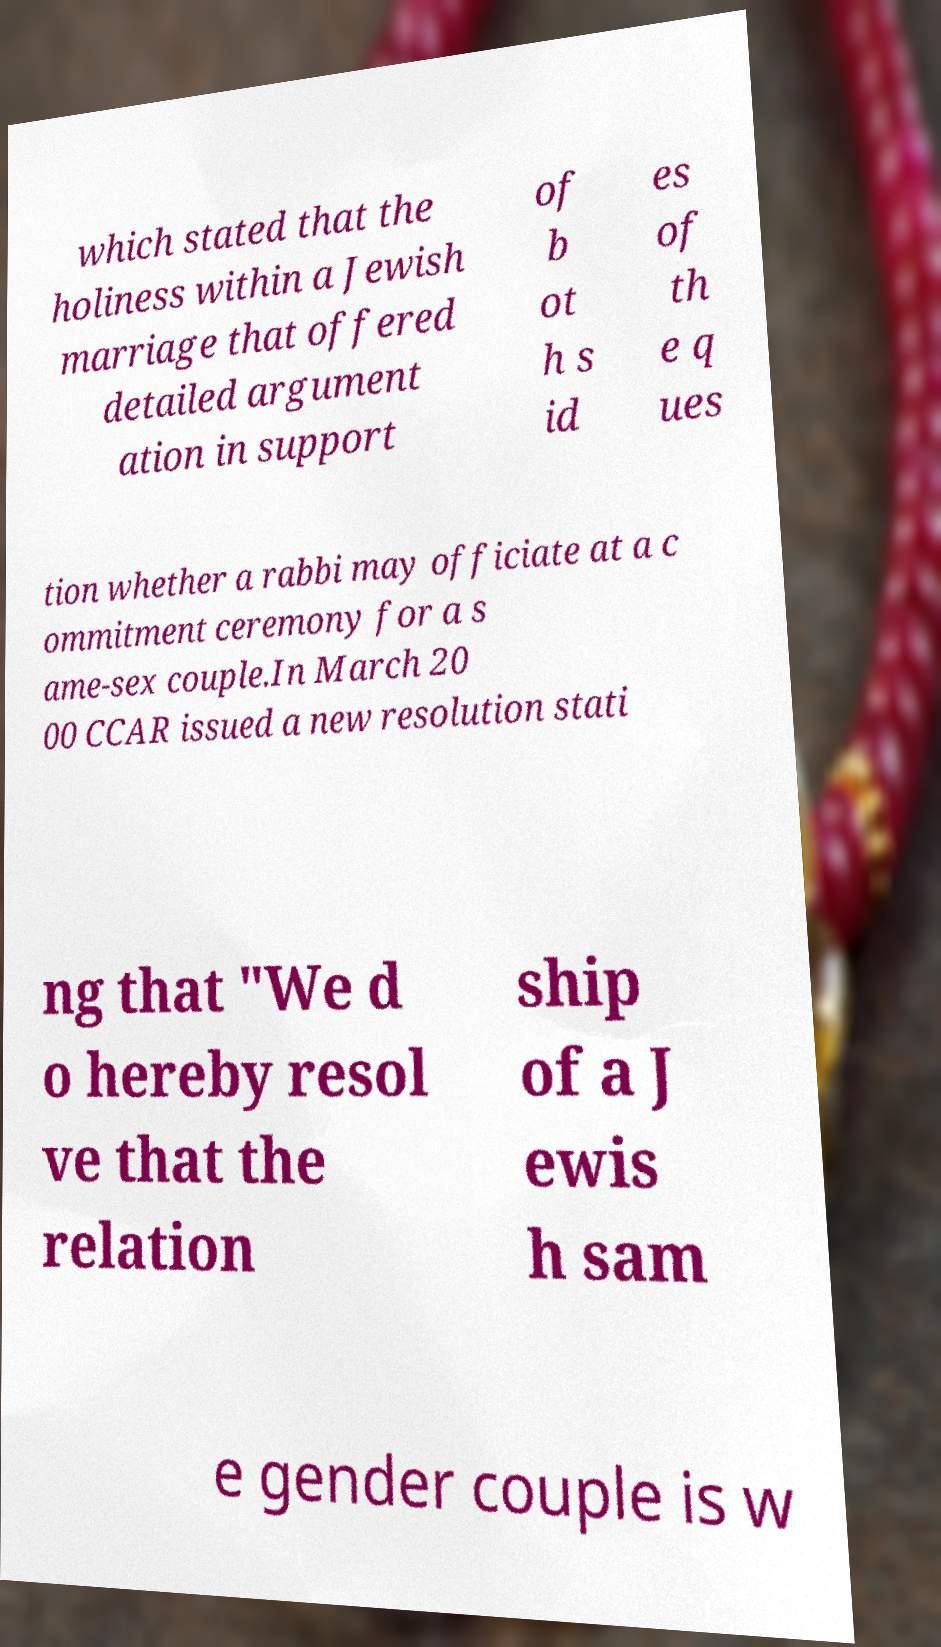Can you read and provide the text displayed in the image?This photo seems to have some interesting text. Can you extract and type it out for me? which stated that the holiness within a Jewish marriage that offered detailed argument ation in support of b ot h s id es of th e q ues tion whether a rabbi may officiate at a c ommitment ceremony for a s ame-sex couple.In March 20 00 CCAR issued a new resolution stati ng that "We d o hereby resol ve that the relation ship of a J ewis h sam e gender couple is w 